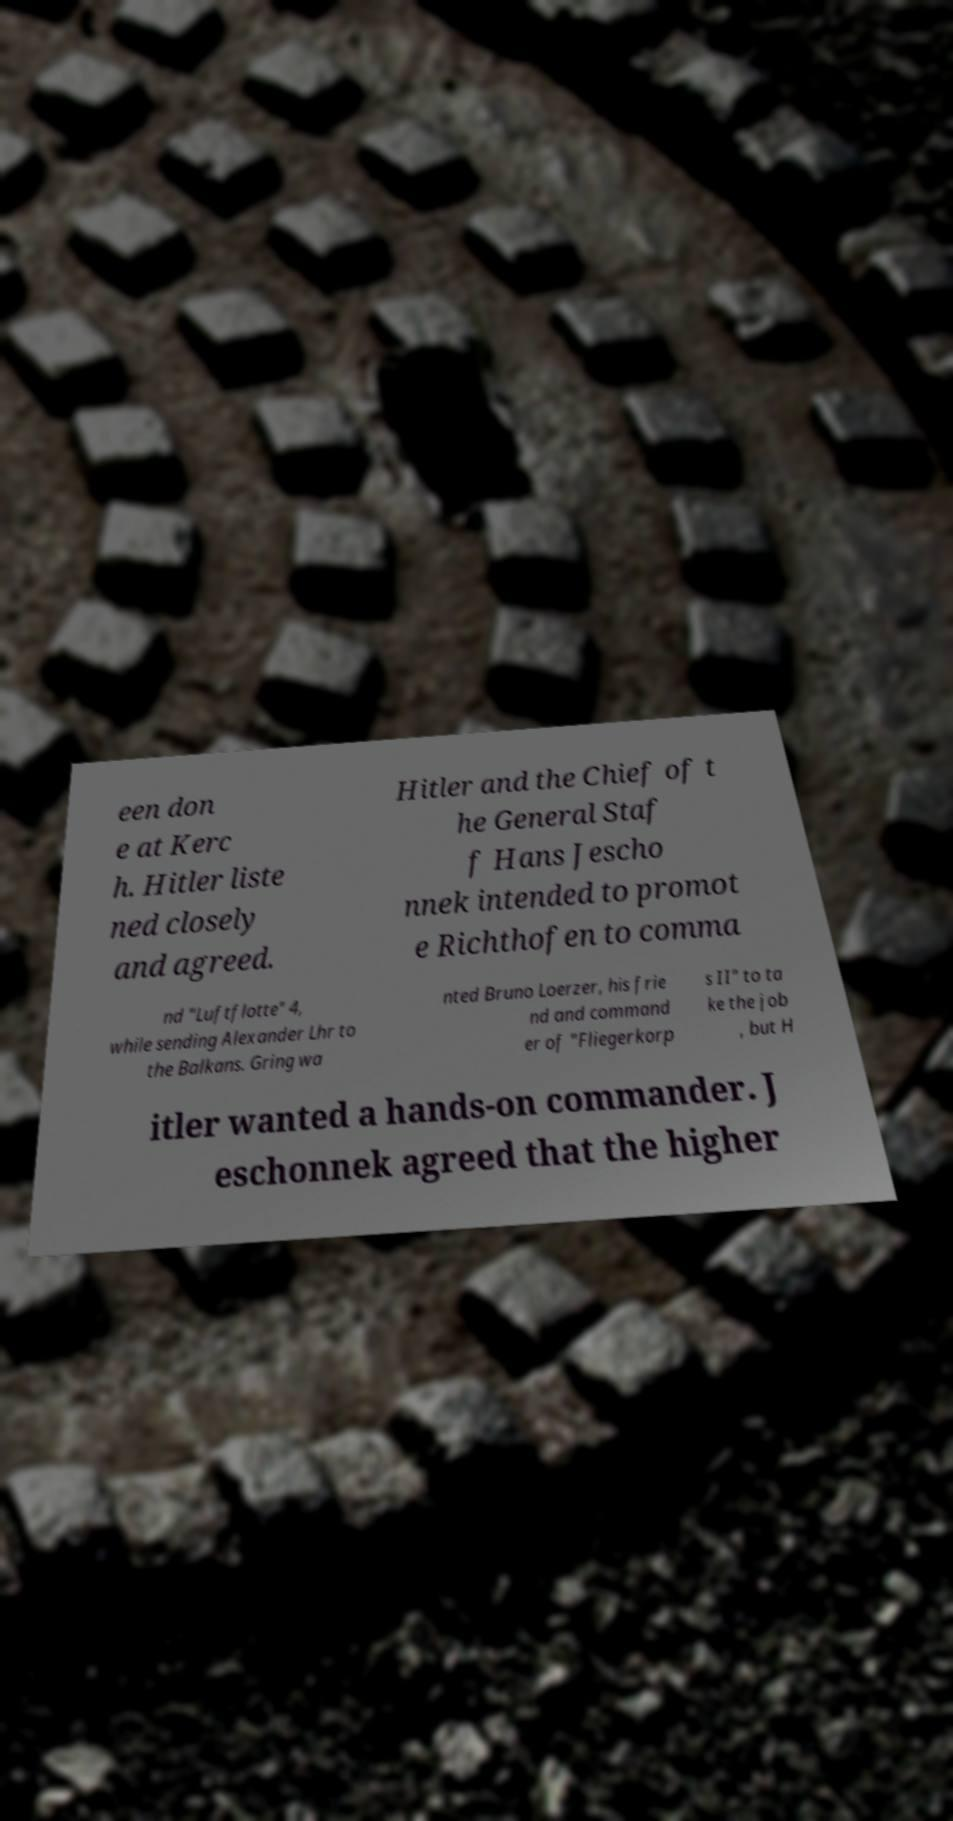I need the written content from this picture converted into text. Can you do that? een don e at Kerc h. Hitler liste ned closely and agreed. Hitler and the Chief of t he General Staf f Hans Jescho nnek intended to promot e Richthofen to comma nd "Luftflotte" 4, while sending Alexander Lhr to the Balkans. Gring wa nted Bruno Loerzer, his frie nd and command er of "Fliegerkorp s II" to ta ke the job , but H itler wanted a hands-on commander. J eschonnek agreed that the higher 